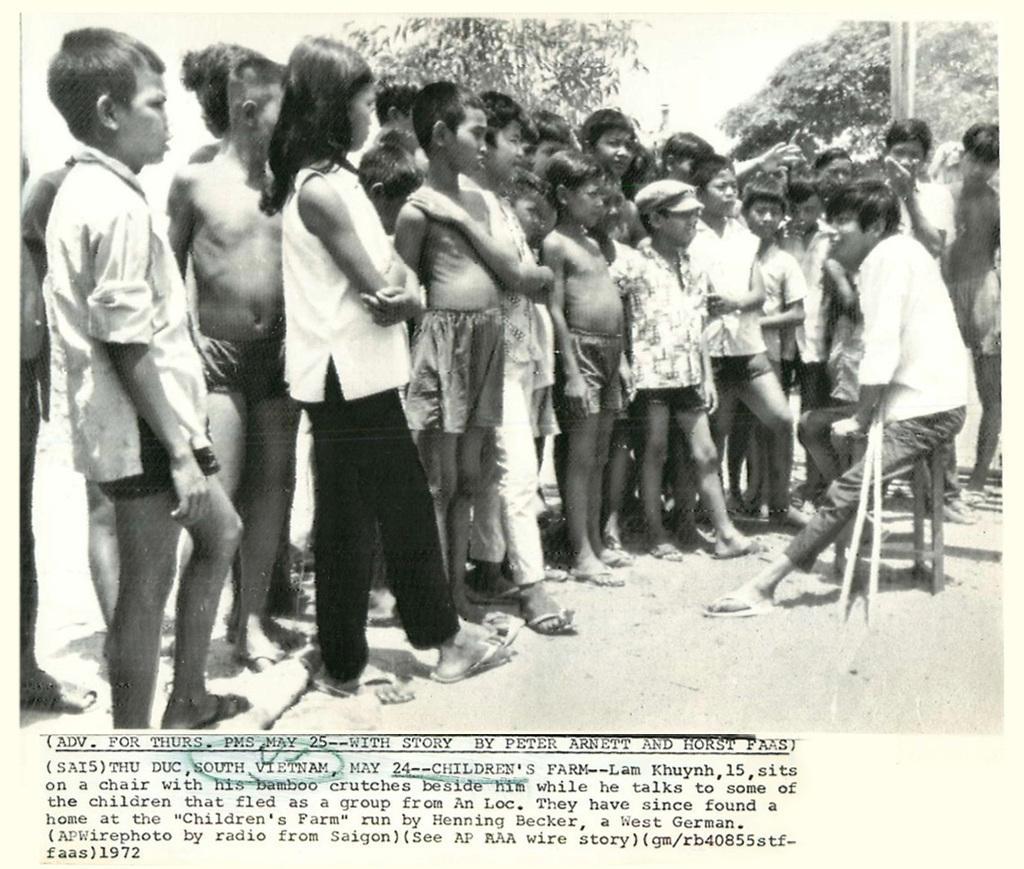Please provide a concise description of this image. In this picture there is a boy who is sitting on a stool on the right side of the image and there are children those who are standing in front of him, there are trees in the background area of the image. 